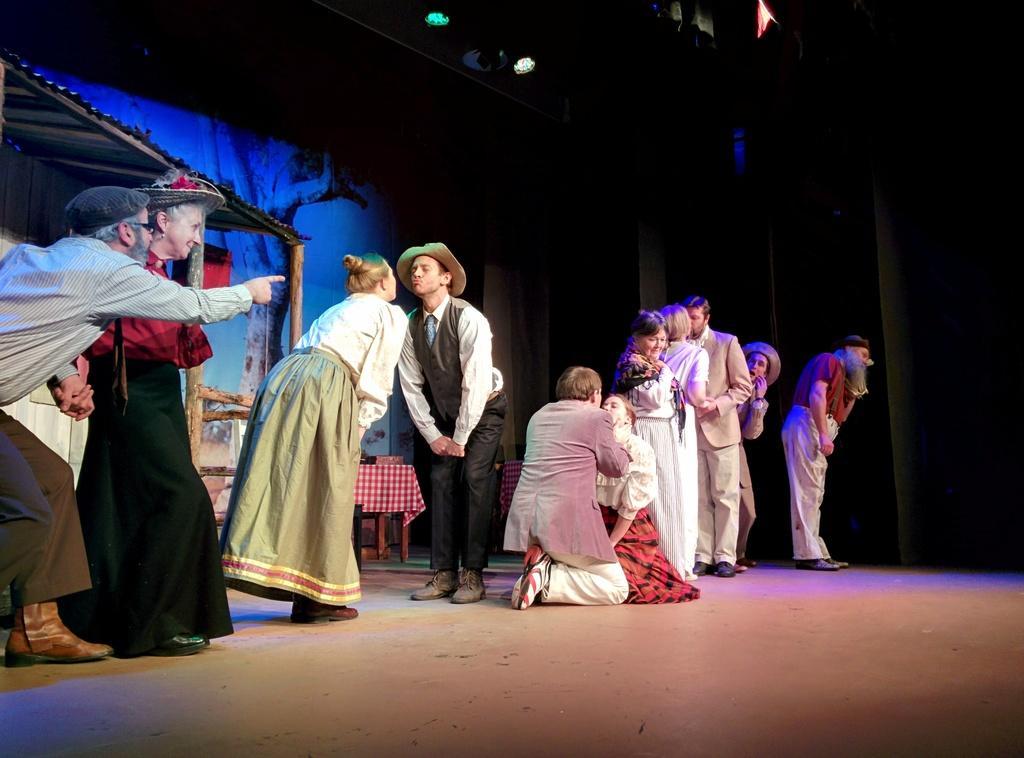Describe this image in one or two sentences. In this picture, we see people performing on the stage. Behind them, we see a shed and a table which is covered with red color cloth. Behind that, we see a banner in blue color. On the right side, it is black in color and this picture might be clicked in the dark. 